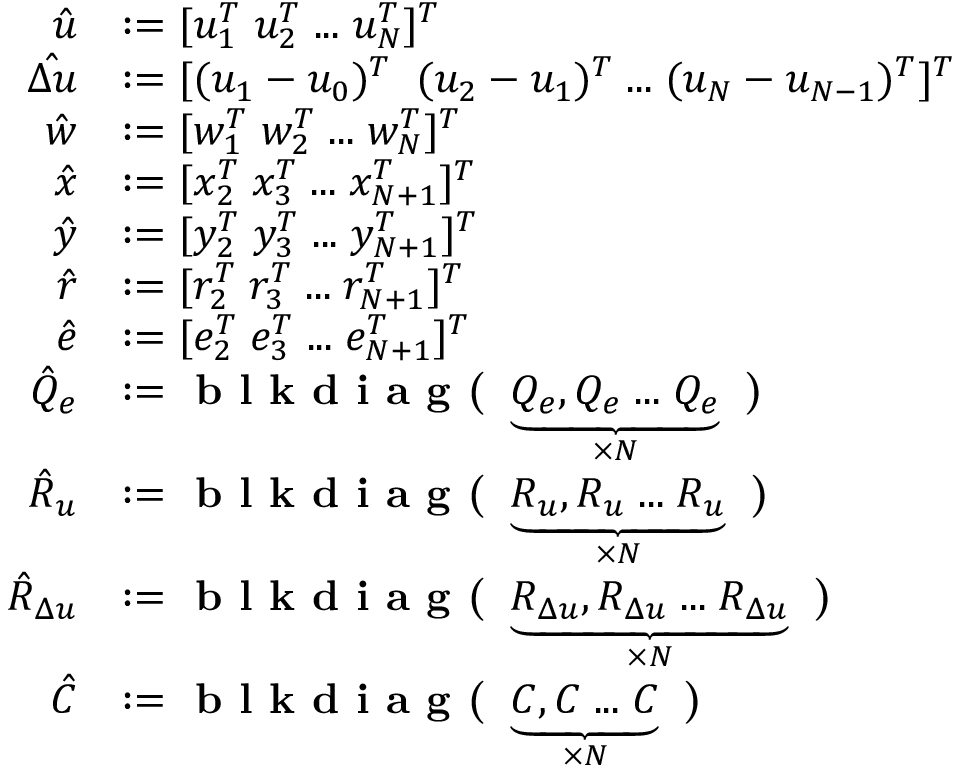Convert formula to latex. <formula><loc_0><loc_0><loc_500><loc_500>\begin{array} { r l } { \hat { u } } & { \colon = [ u _ { 1 } ^ { T } \, u _ { 2 } ^ { T } \, \dots \, u _ { N } ^ { T } ] ^ { T } } \\ { \hat { \Delta u } } & { \colon = [ ( u _ { 1 } - u _ { 0 } ) ^ { T } \, ( u _ { 2 } - u _ { 1 } ) ^ { T } \, \dots \, ( u _ { N } - u _ { N - 1 } ) ^ { T } ] ^ { T } } \\ { \hat { w } } & { \colon = [ w _ { 1 } ^ { T } \, w _ { 2 } ^ { T } \, \dots \, w _ { N } ^ { T } ] ^ { T } } \\ { \hat { x } } & { \colon = [ x _ { 2 } ^ { T } \, x _ { 3 } ^ { T } \, \dots \, x _ { N + 1 } ^ { T } ] ^ { T } } \\ { \hat { y } } & { \colon = [ y _ { 2 } ^ { T } \, y _ { 3 } ^ { T } \, \dots \, y _ { N + 1 } ^ { T } ] ^ { T } } \\ { \hat { r } } & { \colon = [ r _ { 2 } ^ { T } \, r _ { 3 } ^ { T } \, \dots \, r _ { N + 1 } ^ { T } ] ^ { T } } \\ { \hat { e } } & { \colon = [ e _ { 2 } ^ { T } \, e _ { 3 } ^ { T } \, \dots \, e _ { N + 1 } ^ { T } ] ^ { T } } \\ { \hat { Q } _ { e } } & { \colon = b l k d i a g ( \underbrace { Q _ { e } , Q _ { e } \, \dots \, Q _ { e } } _ { \times N } ) } \\ { \hat { R } _ { u } } & { \colon = b l k d i a g ( \underbrace { R _ { u } , R _ { u } \, \dots \, R _ { u } } _ { \times N } ) } \\ { \hat { R } _ { \Delta u } } & { \colon = b l k d i a g ( \underbrace { R _ { \Delta u } , R _ { \Delta u } \, \dots \, R _ { \Delta u } } _ { \times N } ) } \\ { \hat { C } } & { \colon = b l k d i a g ( \underbrace { C , C \, \dots \, C } _ { \times N } ) } \end{array}</formula> 